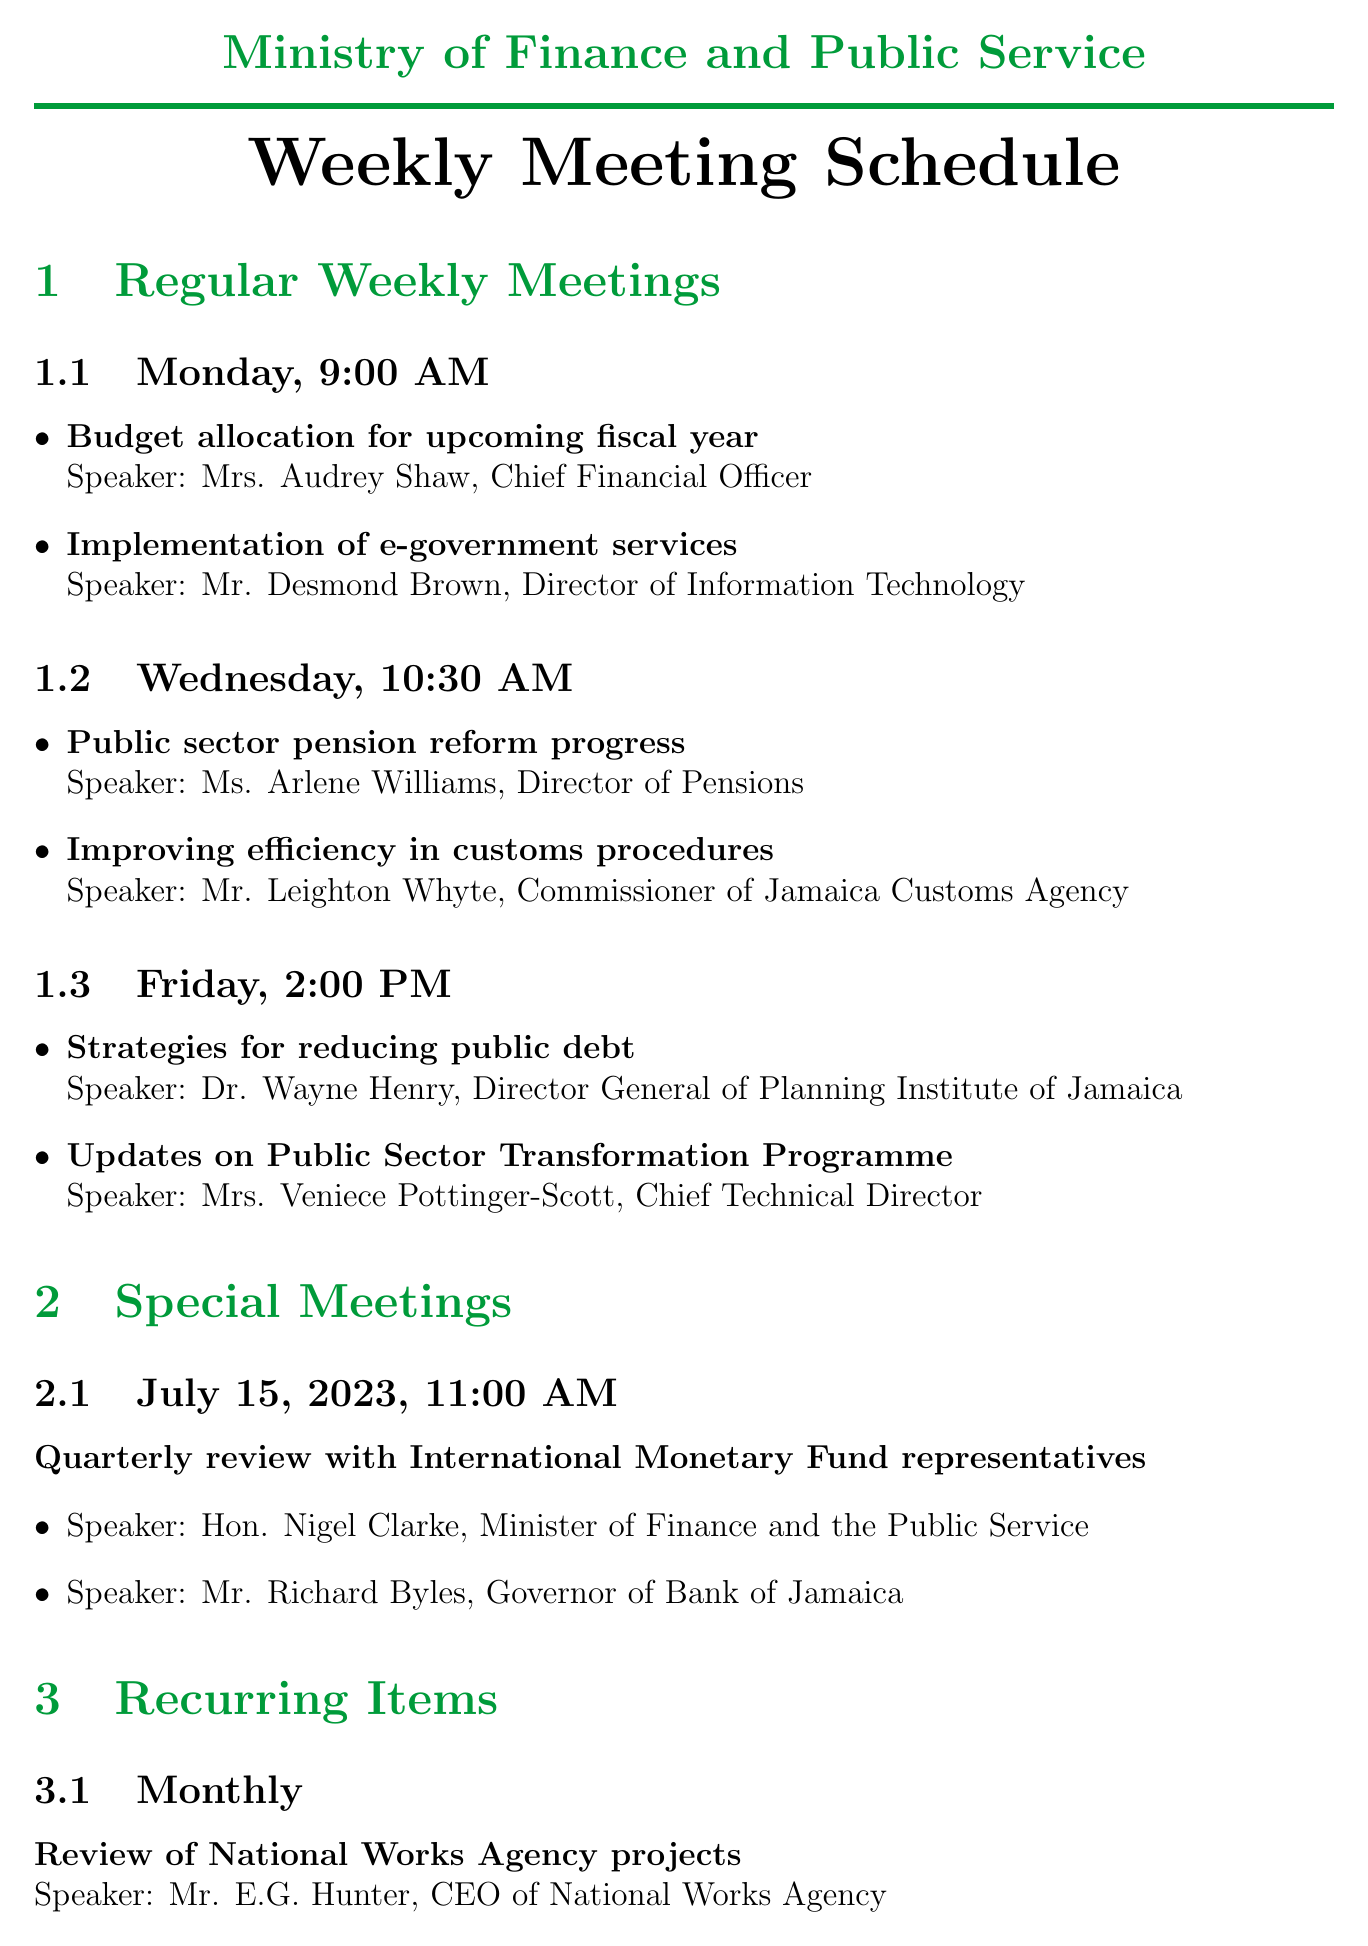what is the agenda item for Monday's meeting? The agenda item for Monday's meeting includes "Budget allocation for upcoming fiscal year" and "Implementation of e-government services."
Answer: Budget allocation for upcoming fiscal year who is the speaker for the Wednesday meeting topic on improving efficiency in customs procedures? The speaker for the topic "Improving efficiency in customs procedures" on Wednesday is identified as Mr. Leighton Whyte, Commissioner of Jamaica Customs Agency.
Answer: Mr. Leighton Whyte what time is the Friday meeting scheduled? The Friday meeting is scheduled at 2:00 PM as mentioned in the document.
Answer: 2:00 PM when is the special meeting with IMF representatives scheduled? The special meeting with IMF representatives is scheduled on July 15, 2023, as per the document.
Answer: July 15, 2023 how often is the review of National Works Agency projects conducted? The review of National Works Agency projects is conducted monthly according to the recurring items listed.
Answer: Monthly who will be presenting on strategies for reducing public debt? The person presenting on "Strategies for reducing public debt" is Dr. Wayne Henry, Director General of Planning Institute of Jamaica.
Answer: Dr. Wayne Henry what is the frequency of updates on Jamaica's Vision 2030 National Development Plan? The frequency for the updates on Jamaica's Vision 2030 National Development Plan is bi-weekly as stated in the recurring items.
Answer: Bi-weekly who is the Chief Financial Officer in the Ministry of Finance and Public Service? The Chief Financial Officer in the Ministry of Finance and Public Service is Mrs. Audrey Shaw.
Answer: Mrs. Audrey Shaw 